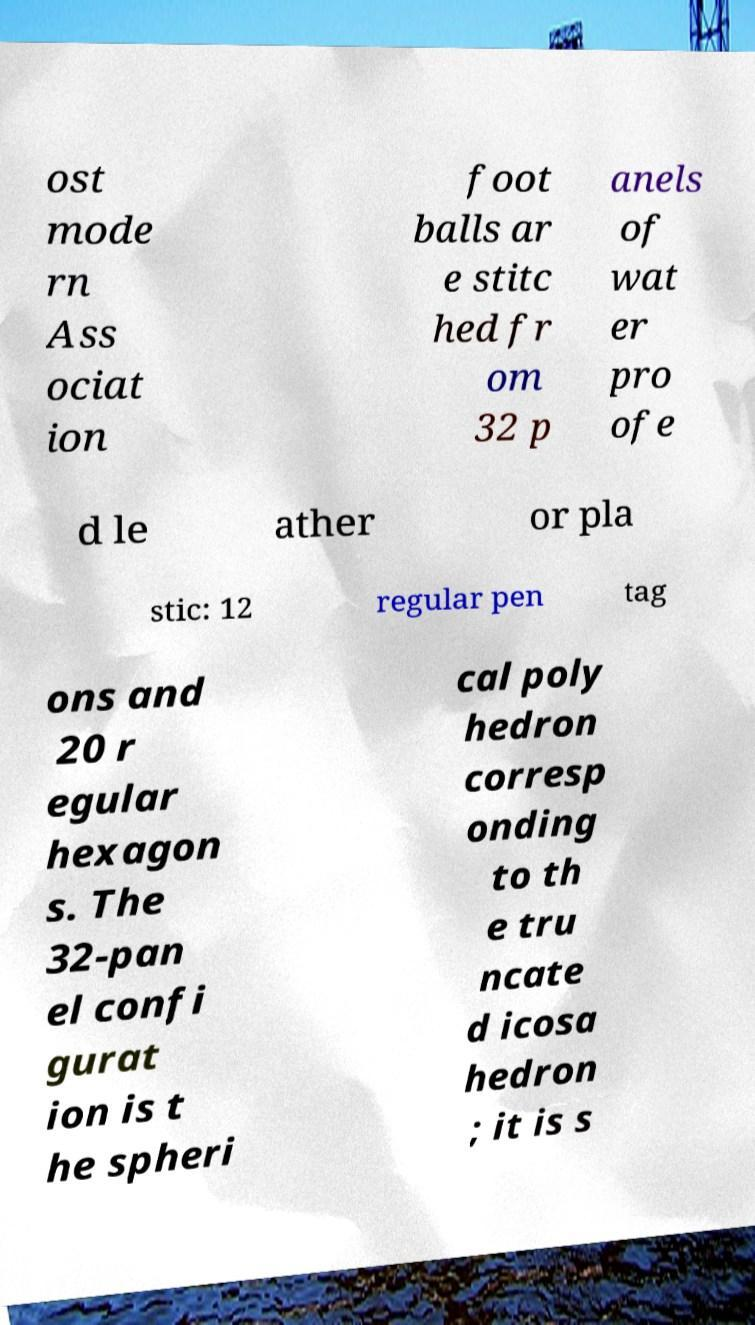Could you extract and type out the text from this image? ost mode rn Ass ociat ion foot balls ar e stitc hed fr om 32 p anels of wat er pro ofe d le ather or pla stic: 12 regular pen tag ons and 20 r egular hexagon s. The 32-pan el confi gurat ion is t he spheri cal poly hedron corresp onding to th e tru ncate d icosa hedron ; it is s 